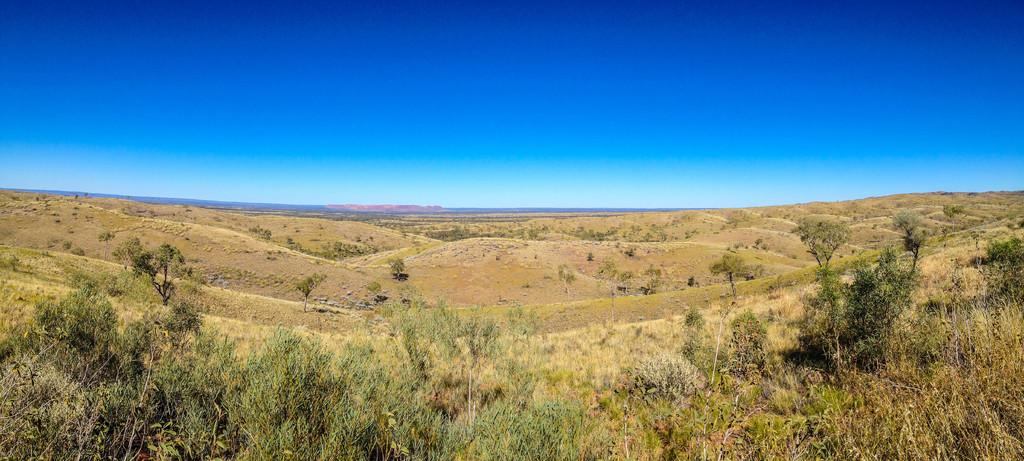What type of terrain is visible in the image? There is an open grass ground in the image. Are there any other natural elements present on the grass ground? Yes, there are trees on the grass ground. What can be seen in the background of the image? The sky is visible in the background of the image. What is the title of the book being read by the tree in the image? There is no book or tree reading a book present in the image. 